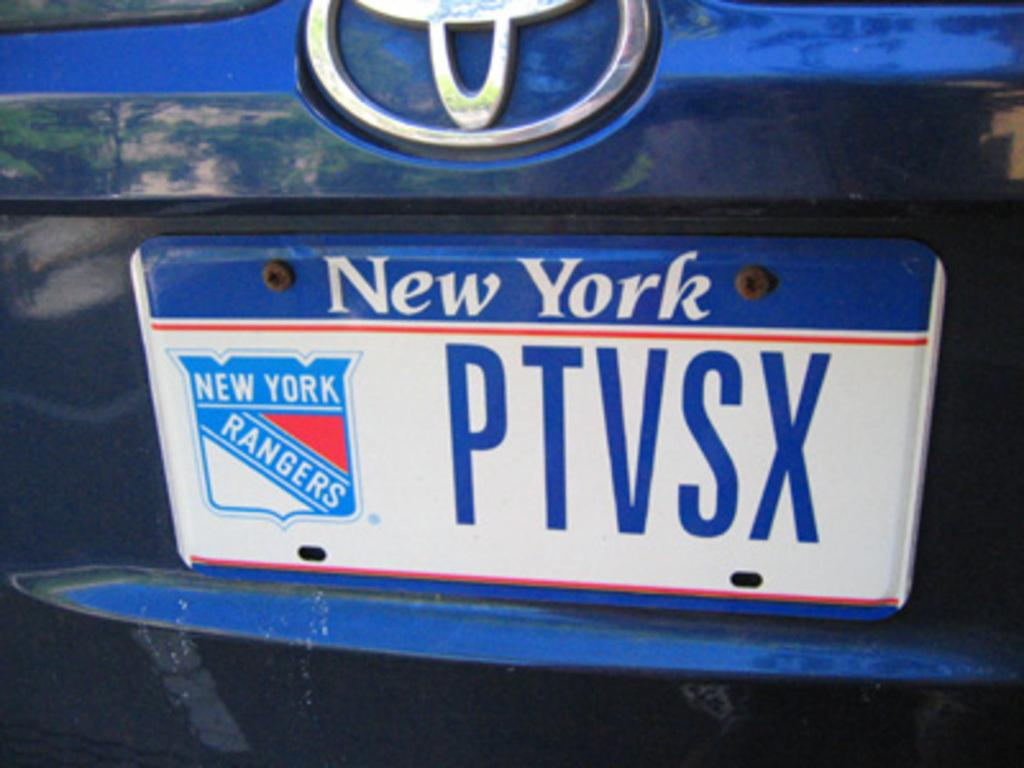<image>
Offer a succinct explanation of the picture presented. A New York license plate with a Rangers logo is on a blue Toyota. 